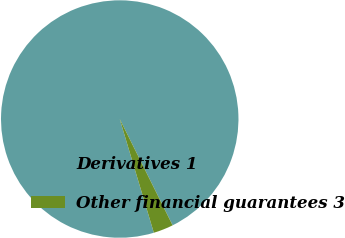<chart> <loc_0><loc_0><loc_500><loc_500><pie_chart><fcel>Derivatives 1<fcel>Other financial guarantees 3<nl><fcel>97.29%<fcel>2.71%<nl></chart> 